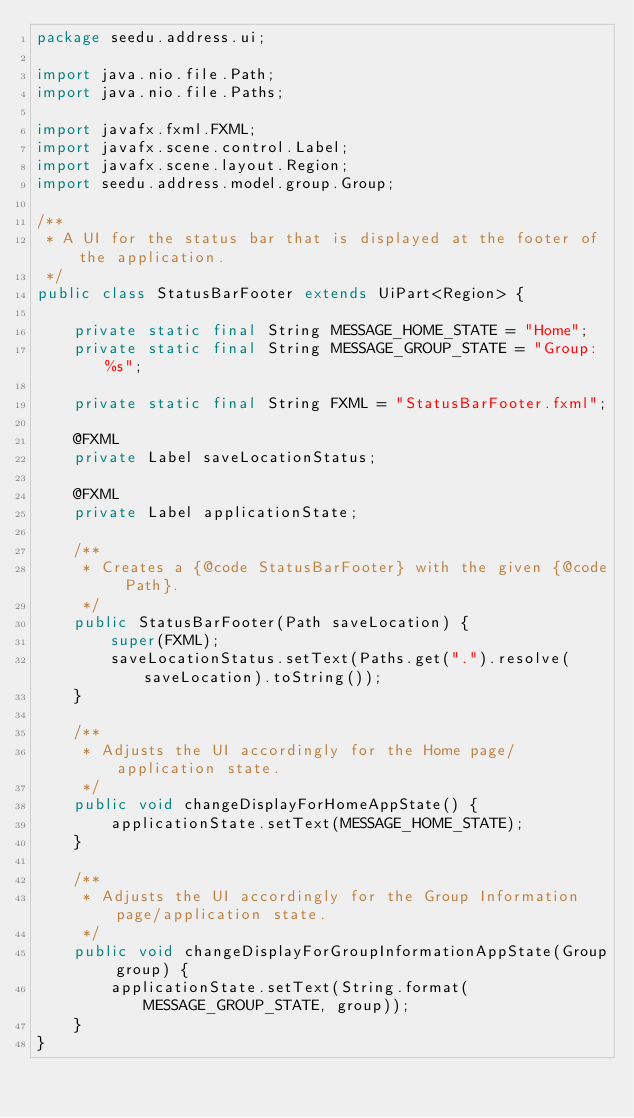<code> <loc_0><loc_0><loc_500><loc_500><_Java_>package seedu.address.ui;

import java.nio.file.Path;
import java.nio.file.Paths;

import javafx.fxml.FXML;
import javafx.scene.control.Label;
import javafx.scene.layout.Region;
import seedu.address.model.group.Group;

/**
 * A UI for the status bar that is displayed at the footer of the application.
 */
public class StatusBarFooter extends UiPart<Region> {

    private static final String MESSAGE_HOME_STATE = "Home";
    private static final String MESSAGE_GROUP_STATE = "Group: %s";

    private static final String FXML = "StatusBarFooter.fxml";

    @FXML
    private Label saveLocationStatus;

    @FXML
    private Label applicationState;

    /**
     * Creates a {@code StatusBarFooter} with the given {@code Path}.
     */
    public StatusBarFooter(Path saveLocation) {
        super(FXML);
        saveLocationStatus.setText(Paths.get(".").resolve(saveLocation).toString());
    }

    /**
     * Adjusts the UI accordingly for the Home page/application state.
     */
    public void changeDisplayForHomeAppState() {
        applicationState.setText(MESSAGE_HOME_STATE);
    }

    /**
     * Adjusts the UI accordingly for the Group Information page/application state.
     */
    public void changeDisplayForGroupInformationAppState(Group group) {
        applicationState.setText(String.format(MESSAGE_GROUP_STATE, group));
    }
}
</code> 